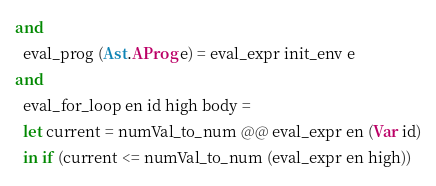<code> <loc_0><loc_0><loc_500><loc_500><_OCaml_>and
  eval_prog (Ast.AProg e) = eval_expr init_env e
and
  eval_for_loop en id high body =
  let current = numVal_to_num @@ eval_expr en (Var id)
  in if (current <= numVal_to_num (eval_expr en high))</code> 